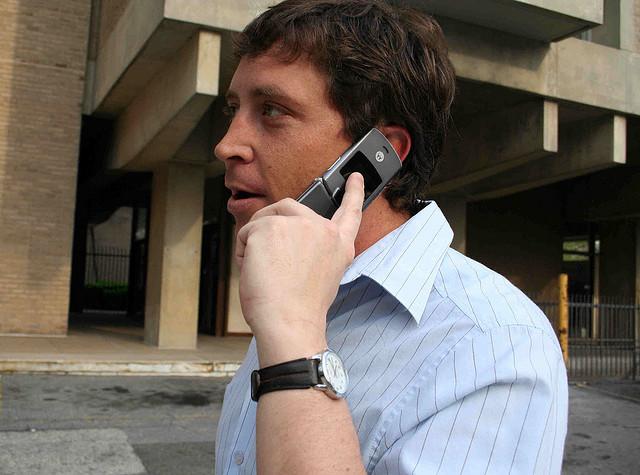What is the building in the background made of?
Keep it brief. Concrete. What is the pattern on his shirt?
Write a very short answer. Stripes. Does the man have sunglasses on?
Give a very brief answer. No. Is this man wearing a watch?
Write a very short answer. Yes. What is this person doing?
Give a very brief answer. Talking on phone. Does the man have on sunglasses?
Keep it brief. No. 